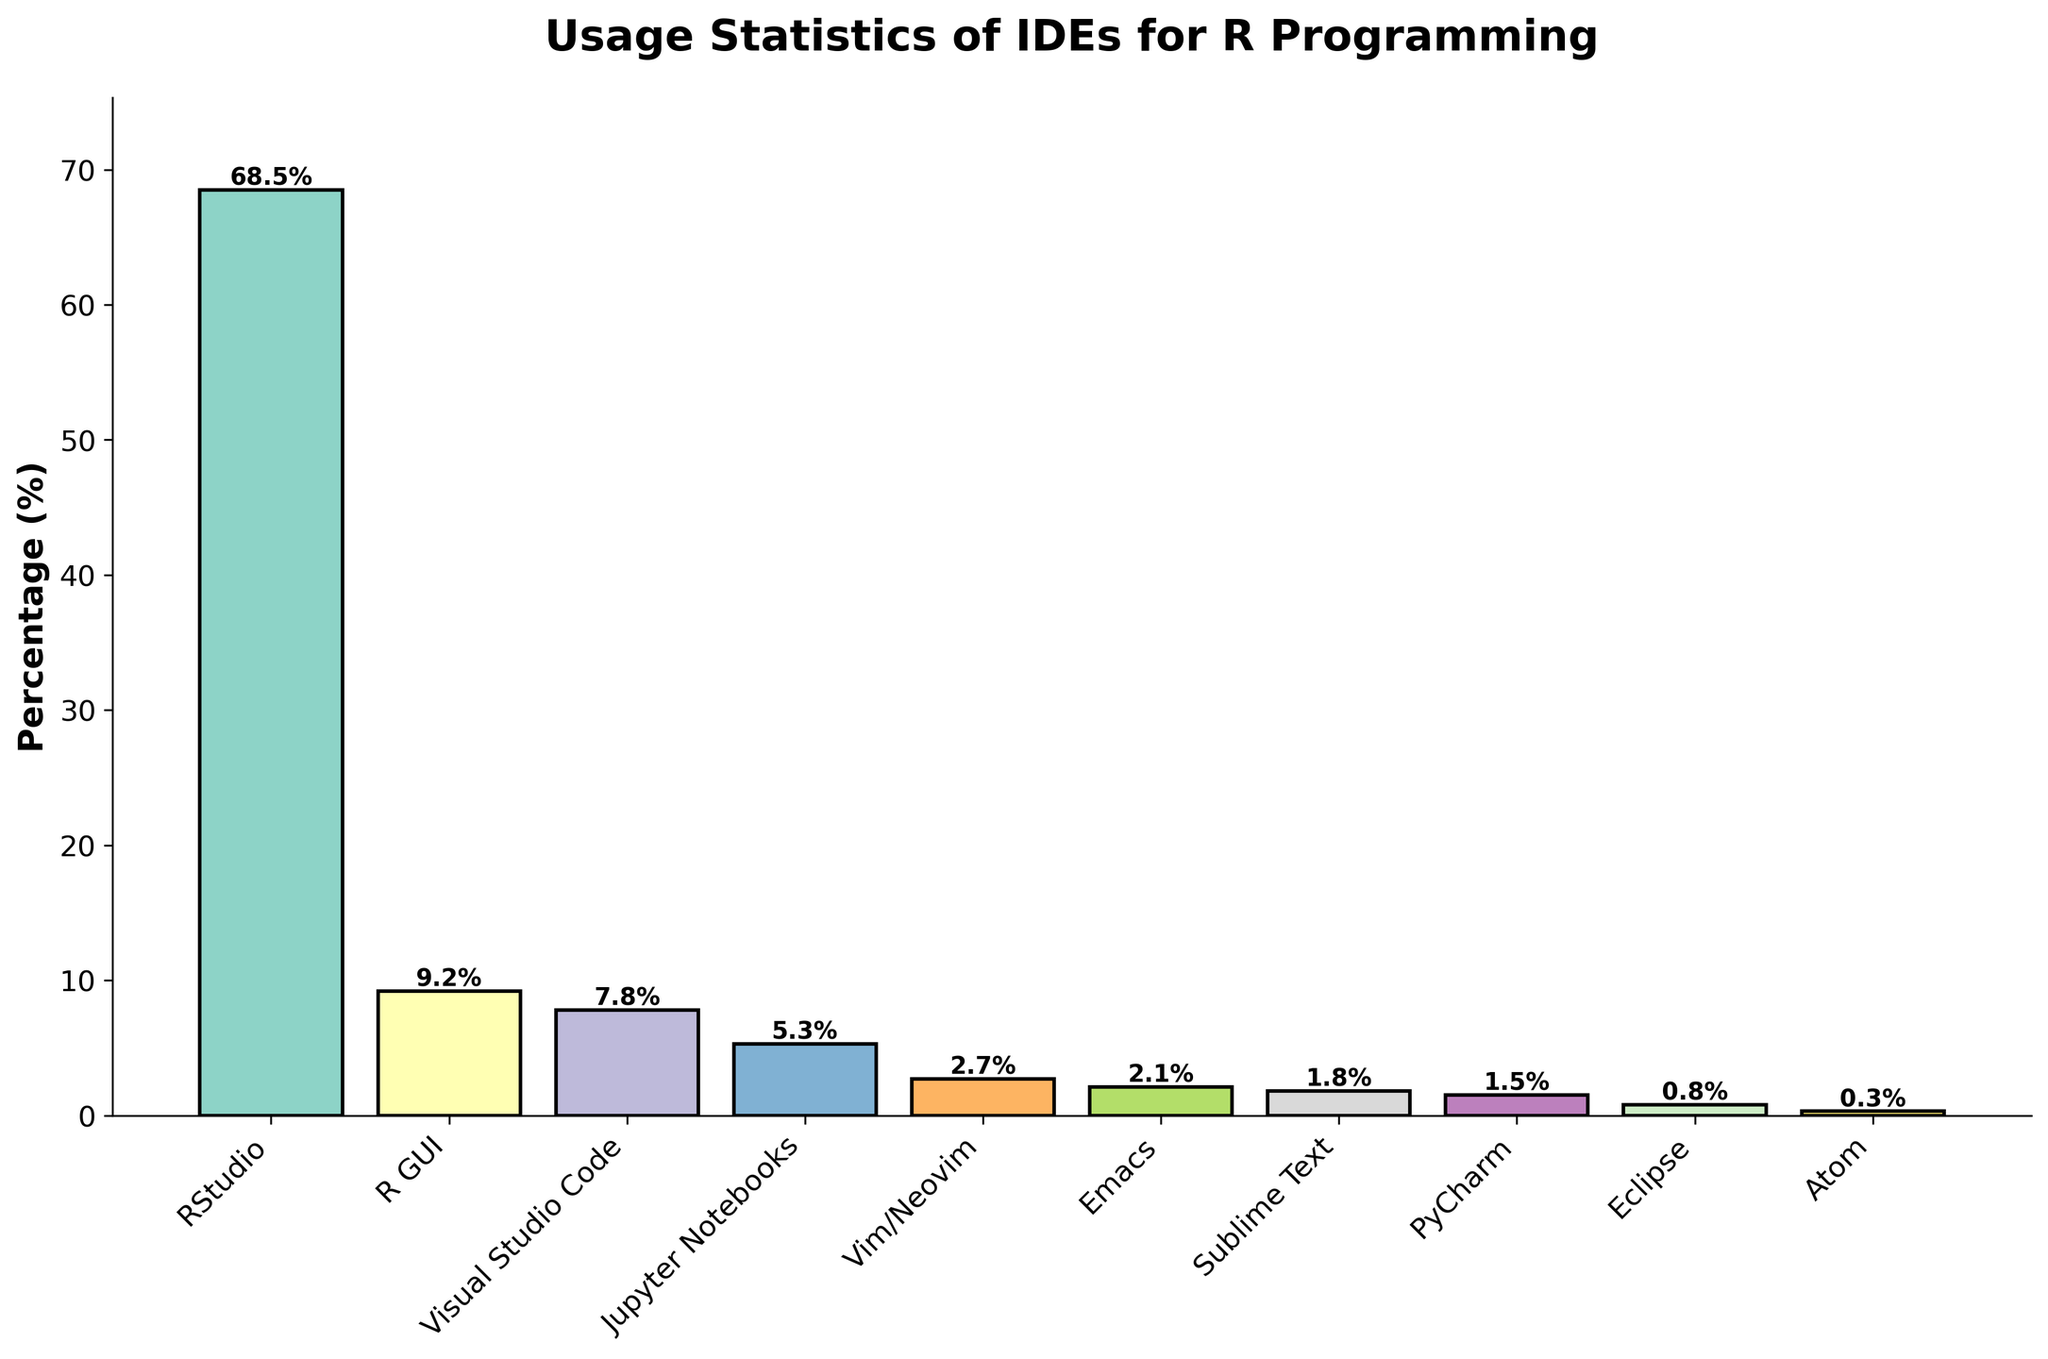Which IDE has the highest usage percentage? The bar for RStudio is the tallest, representing the highest percentage among all IDEs shown in the figure.
Answer: RStudio What's the combined usage percentage of RStudio and Visual Studio Code? Adding the percentages of RStudio (68.5) and Visual Studio Code (7.8) yields a total of 76.3%.
Answer: 76.3% How many IDEs have a usage percentage of less than 2%? By counting the bars representing IDEs with percentages below 2% (Sublime Text, PyCharm, Eclipse, Atom), there are four such IDEs.
Answer: 4 Is the usage percentage of R GUI more than twice that of Jupyter Notebooks? The percentage for R GUI is 9.2, and for Jupyter Notebooks is 5.3. Doubling Jupyter Notebooks' percentage gives 10.6, which is greater than 9.2.
Answer: No Which IDE shows the least usage, and what is its percentage? The shortest bar corresponds to Atom, with a percentage of 0.3.
Answer: Atom, 0.3% What is the difference in usage percentage between Vim/Neovim and Emacs? Subtracting the percentage of Emacs (2.1) from Vim/Neovim (2.7) gives a difference of 0.6.
Answer: 0.6% What is the total usage percentage for IDEs with less than 1% usage? Adding the percentages of IDEs with less than 1% usage (Eclipse: 0.8 and Atom: 0.3) results in a total of 1.1%.
Answer: 1.1% Which IDEs have a usage percentage between 5% and 10%? The bars for IDEs with percentages in this range are R GUI (9.2) and Visual Studio Code (7.8).
Answer: R GUI, Visual Studio Code What percentage of users are using IDEs other than the top three? Subtracting the combined percentages of RStudio (68.5), R GUI (9.2), and Visual Studio Code (7.8) from 100% gives 14.5%.
Answer: 14.5% Is the average usage percentage of the bottom five IDEs more or less than 2%? The bottom five IDEs (Emacs: 2.1, Sublime Text: 1.8, PyCharm: 1.5, Eclipse: 0.8, Atom: 0.3) add up to 6.5%. Dividing 6.5 by 5 yields an average of 1.3, which is less than 2%.
Answer: Less 